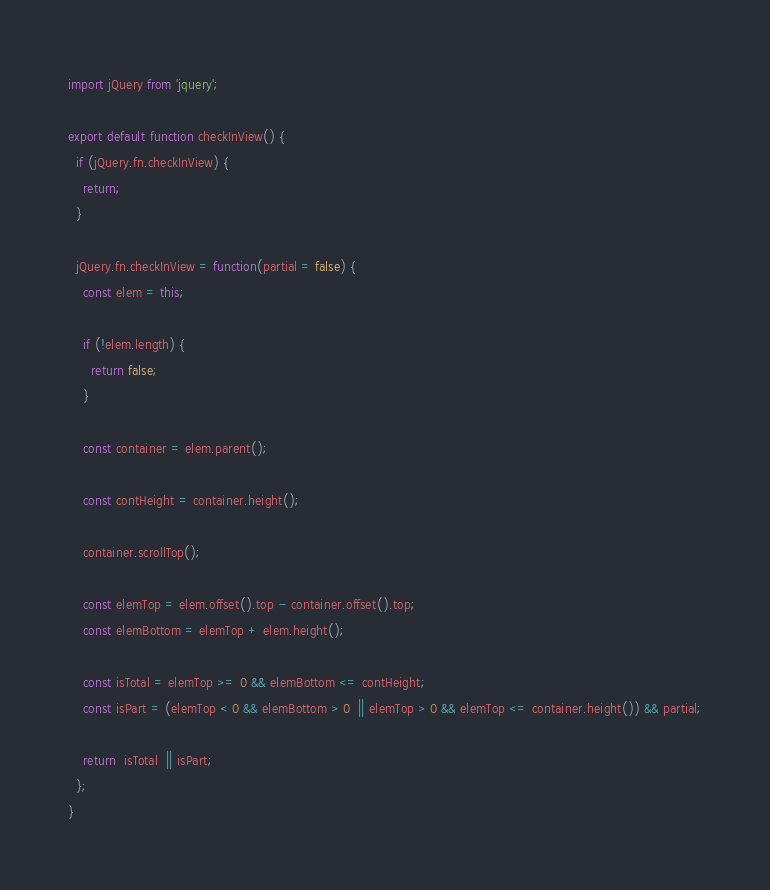Convert code to text. <code><loc_0><loc_0><loc_500><loc_500><_JavaScript_>import jQuery from 'jquery';

export default function checkInView() {
  if (jQuery.fn.checkInView) {
    return;
  }

  jQuery.fn.checkInView = function(partial = false) {
    const elem = this;

    if (!elem.length) {
      return false;
    }

    const container = elem.parent();

    const contHeight = container.height();

    container.scrollTop();

    const elemTop = elem.offset().top - container.offset().top;
    const elemBottom = elemTop + elem.height();

    const isTotal = elemTop >= 0 && elemBottom <= contHeight;
    const isPart = (elemTop < 0 && elemBottom > 0  || elemTop > 0 && elemTop <= container.height()) && partial;

    return  isTotal  || isPart;
  };
}
</code> 